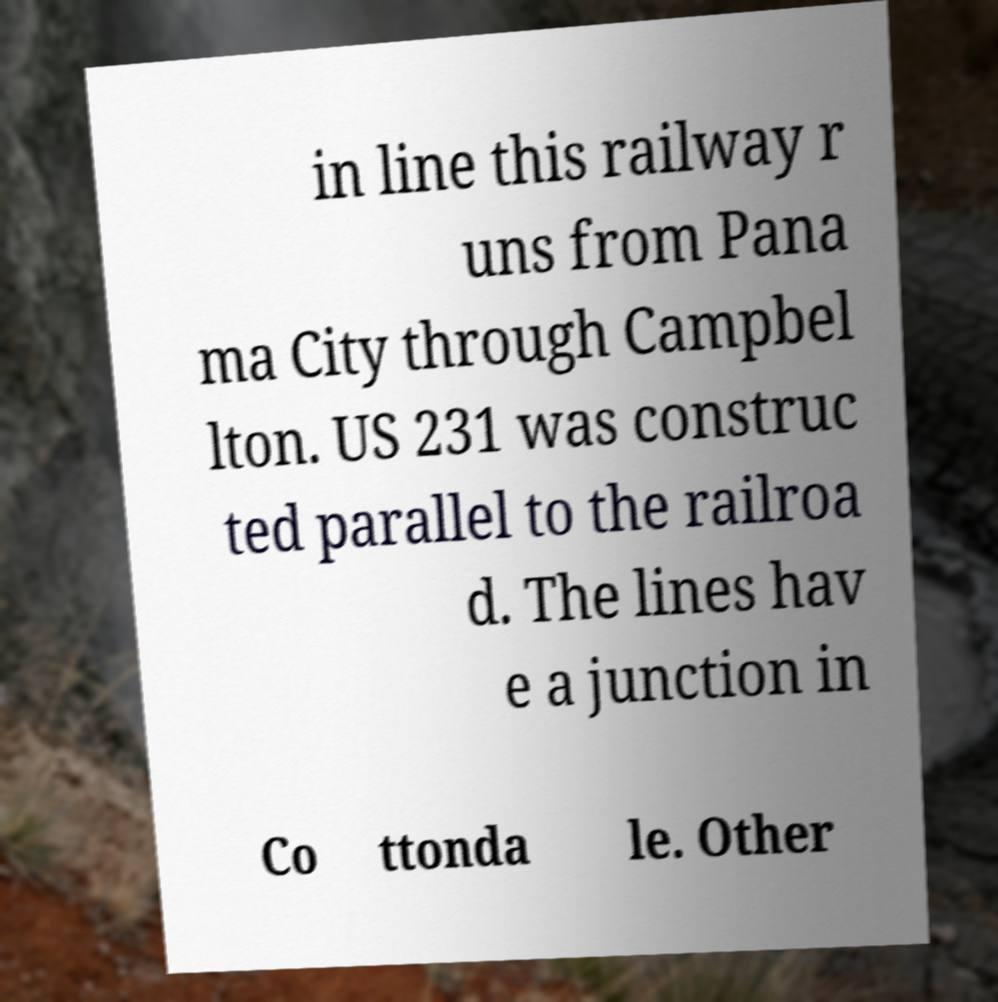Could you extract and type out the text from this image? in line this railway r uns from Pana ma City through Campbel lton. US 231 was construc ted parallel to the railroa d. The lines hav e a junction in Co ttonda le. Other 